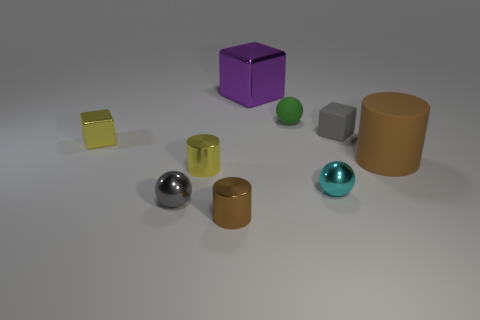What material is the brown cylinder that is in front of the gray thing that is in front of the large cylinder made of?
Provide a short and direct response. Metal. There is a yellow cylinder that is the same size as the gray sphere; what is it made of?
Your response must be concise. Metal. Do the brown object on the left side of the rubber cylinder and the green sphere have the same size?
Give a very brief answer. Yes. Do the small yellow thing behind the large brown matte thing and the large metal thing have the same shape?
Ensure brevity in your answer.  Yes. Are there fewer green objects than cylinders?
Make the answer very short. Yes. Are there more small yellow objects than tiny red shiny cylinders?
Offer a very short reply. Yes. How many other things are there of the same material as the small green thing?
Offer a terse response. 2. There is a small gray object behind the yellow thing that is in front of the small yellow metal block; what number of shiny objects are behind it?
Provide a short and direct response. 1. How many metallic objects are large cylinders or blue cylinders?
Offer a very short reply. 0. What is the size of the gray object to the left of the metal cylinder in front of the small cyan shiny thing?
Provide a succinct answer. Small. 